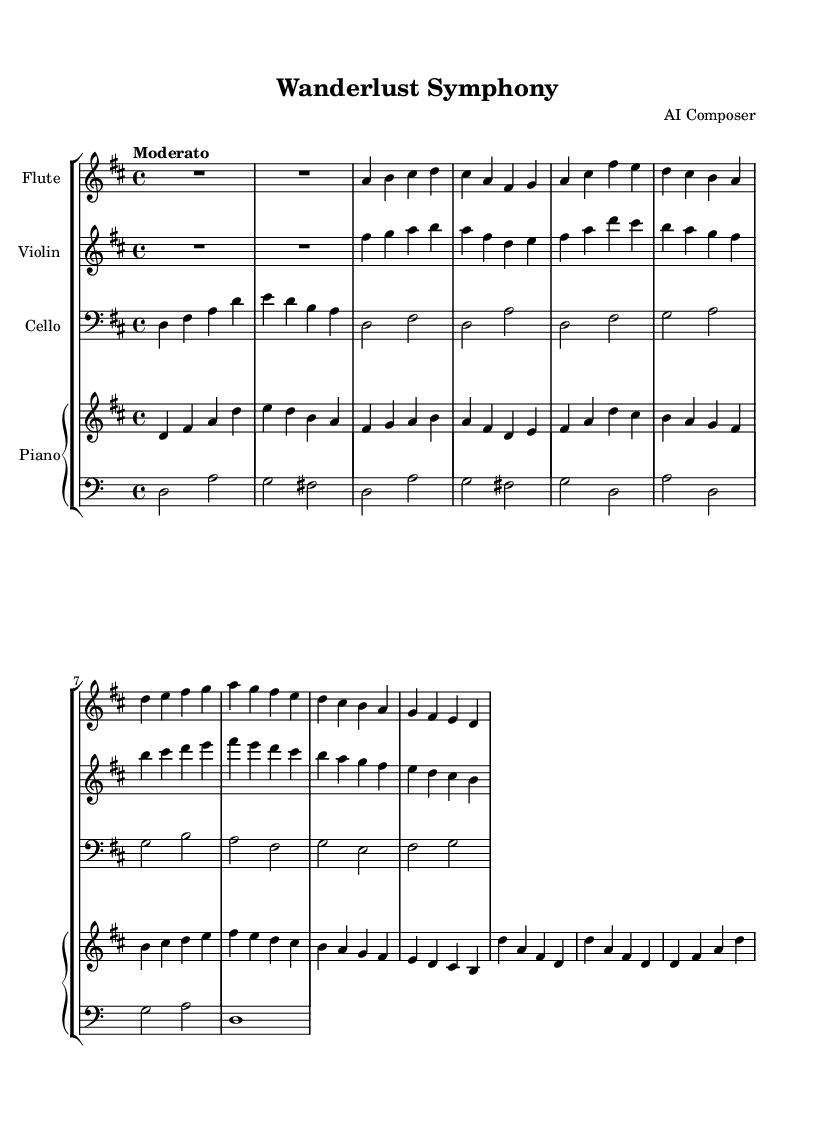What is the key signature of this music? The key signature is indicated at the beginning of the score. It shows two sharps, which correspond to the notes F# and C#. Hence, this indicates the key of D major.
Answer: D major What is the time signature of the piece? The time signature is located at the beginning of the score and shows a '4/4' at the start, which means there are four beats in a measure.
Answer: 4/4 What is the tempo marking for this symphony? The tempo is indicated at the beginning of the piece with the word "Moderato", which suggests a moderate pace of performance.
Answer: Moderato Which instrument plays Theme A first? By analyzing the score, Theme A is first played by the violin since it starts playing right after the initial rest in measures.
Answer: Violin How many total measures are in the piece? By counting each measure within the score, including all sections (Introduction, Theme A, Theme B, and Coda), you determine that there are a total of 16 measures in this piece.
Answer: 16 What instrument plays the lowest range? The cello part is the lowest in range as it is written in the bass clef and typically plays lower pitch notes compared to the other instruments, such as the flute and violin.
Answer: Cello What significant cultural theme is reflected in the title of the piece? The title "Wanderlust Symphony" suggests a theme of travel and cultural exchange, which is common in contemporary classical compositions inspired by experiences from different cultures and places.
Answer: Wanderlust 